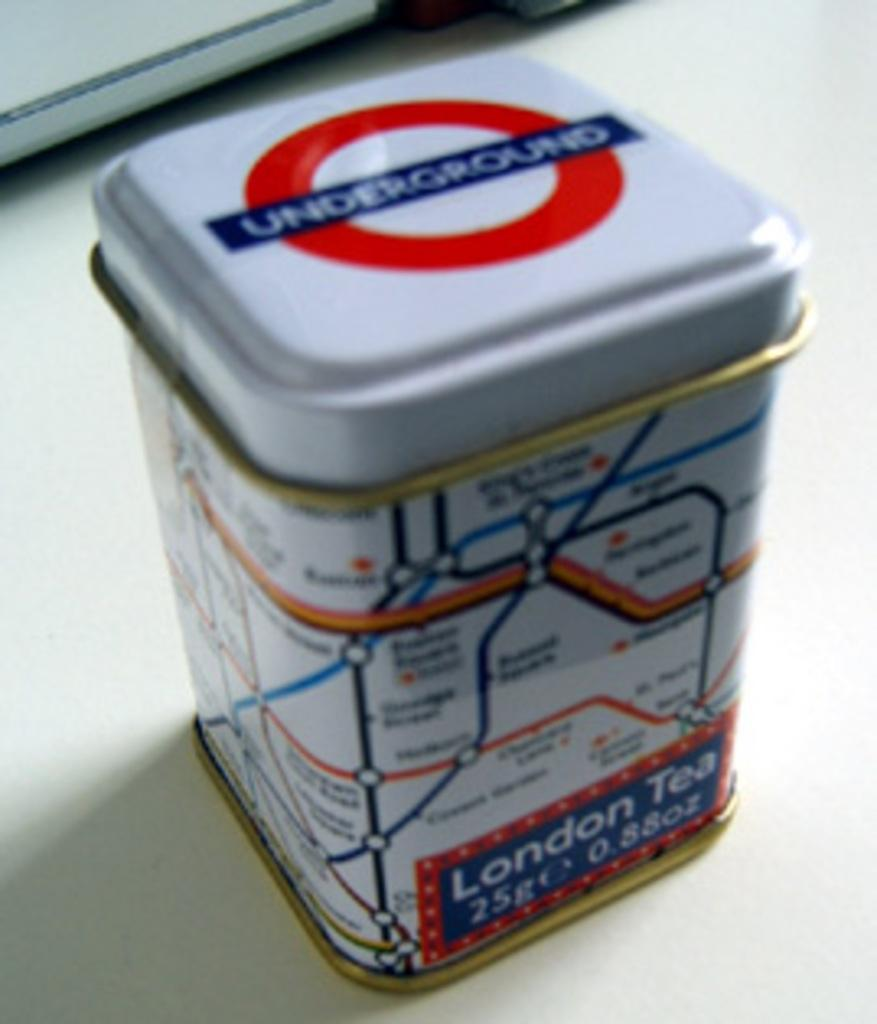<image>
Render a clear and concise summary of the photo. A white tin has a map on it and says London Tea. 